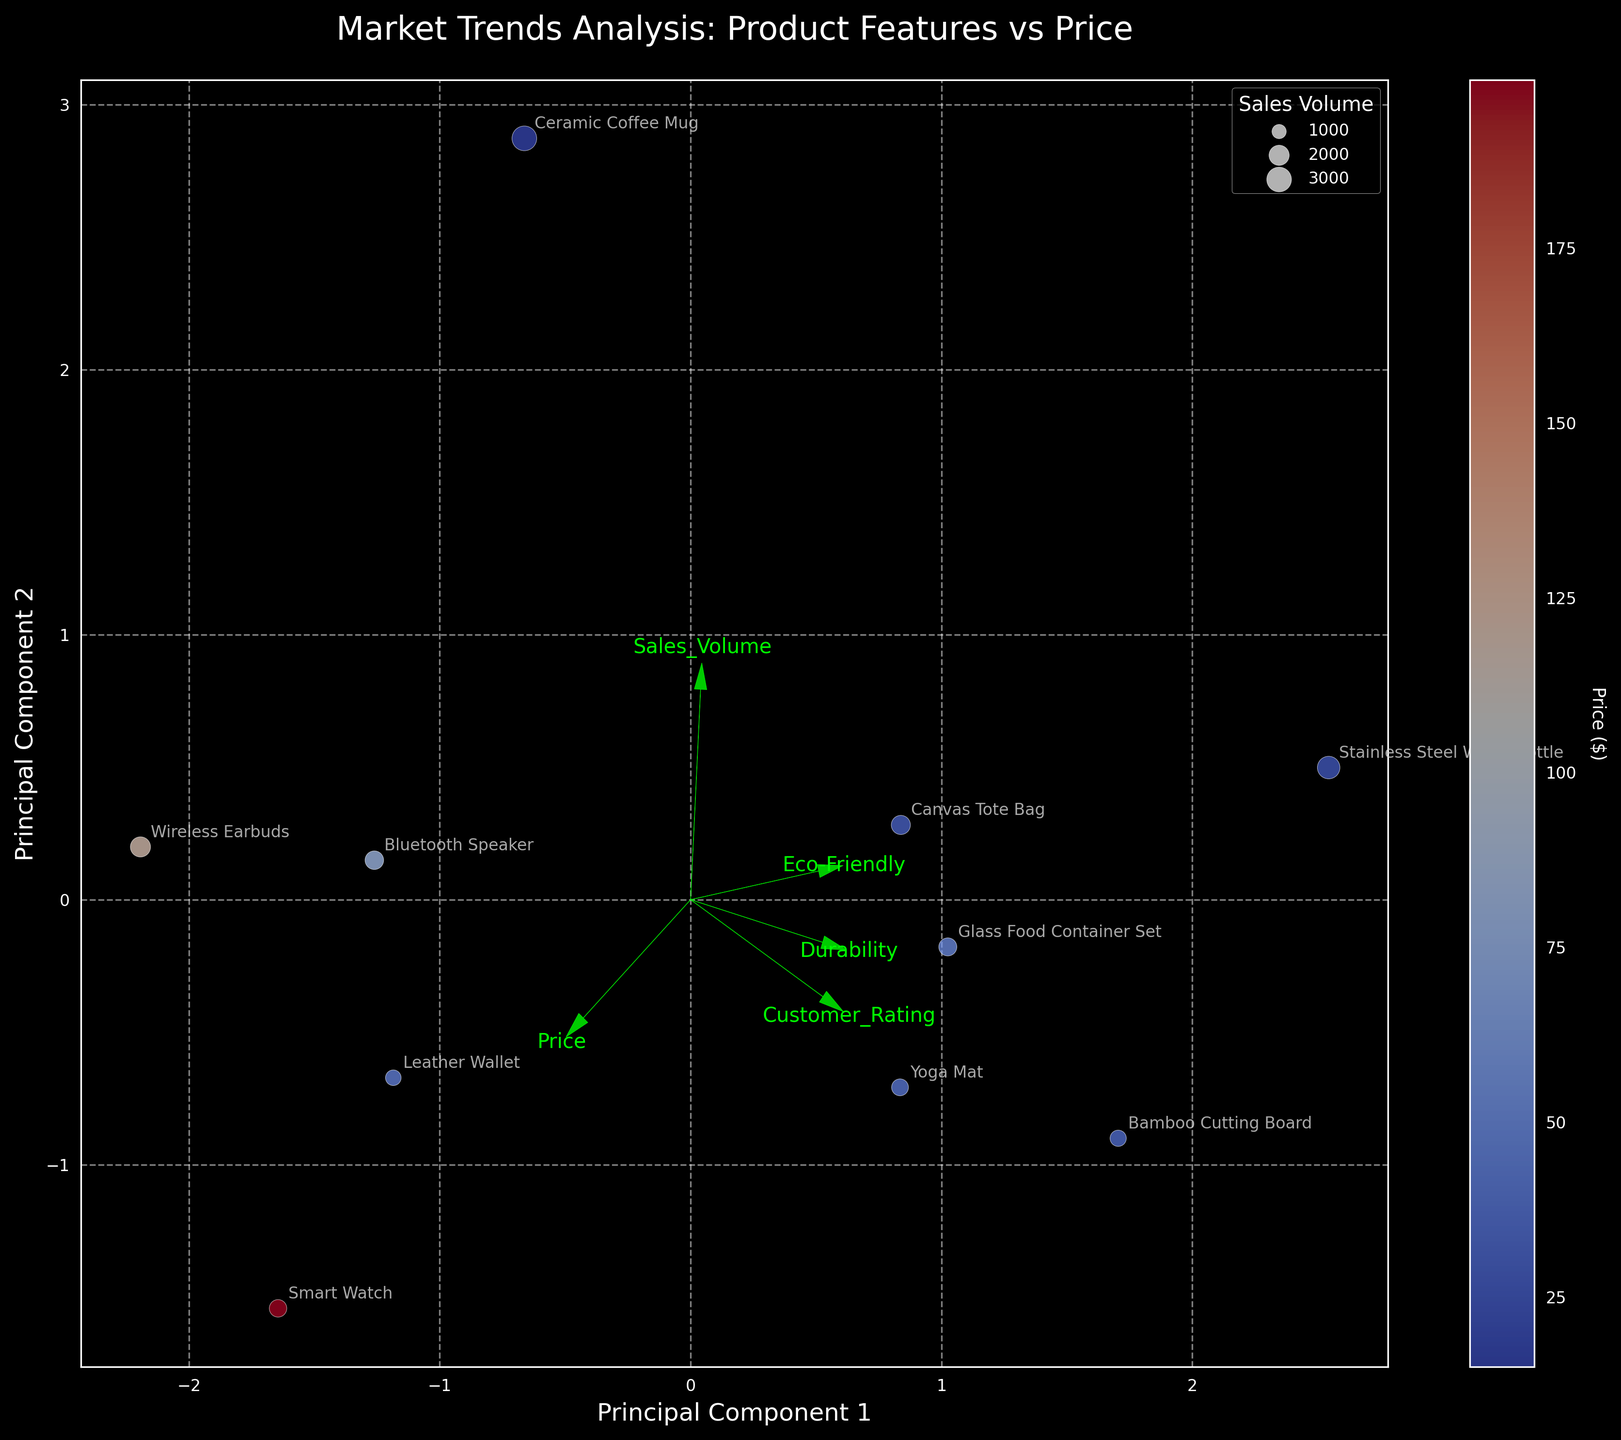How many products are displayed in the plot? Count the number of unique data points annotated with product names on the biplot. There are visible points like "Leather Wallet", "Canvas Tote Bag", and so on. Counting all annotated points gives the total number of products.
Answer: 10 Which feature has the longest vector in the biplot? Look for the green arrows representing features. Identify the arrow with the greatest magnitude (length). The longest vector signifies the feature that contributes most significantly to the variance in the data along the principal components.
Answer: Sales_Volume Which product has the highest sales volume, and where is it located on the plot? Identify the data point with the largest bubble size, since bubble size represents sales volume. Look for the "Ceramic Coffee Mug" annotation near this largest bubble size. It is found on the right side of the plot.
Answer: Ceramic Coffee Mug, right side Which feature has the strongest positive correlation with Principal Component 1? Check the arrows representing features. The feature arrow that most closely aligns with the positive direction of the Principal Component 1 axis indicates the strongest positive correlation with this axis.
Answer: Sales_Volume How does the price affect the position of products on the plot? Observing the color gradient on the bubbles, cooler colors (blues) indicate lower prices, while warmer colors (reds) represent higher prices. Products with higher prices appear to cluster on a specific region in the plot due to the color gradient.
Answer: Higher-priced products are found in the same region Which product is rated the highest by customers, and what is its position on the plot? Look for the product with the highest Customer_Rating feature, which is "Stainless Steel Water Bottle" rated at 4.7. Locate its annotation on the plot, which should be near a moderately sized bubble towards the top.
Answer: Stainless Steel Water Bottle, top region What can be inferred about the relationship between eco-friendliness and sales volume from the biplot? Look at the direction and length of the "Eco-Friendly" vector compared to "Sales_Volume". Both vectors point in somewhat similar directions, suggesting a positive relationship. Products with higher eco-friendliness tend to cluster where bubbles are relatively larger (indicating higher sales).
Answer: More eco-friendly products often have higher sales volumes Is there a noticeable pattern among products with high durability in terms of sales volume? Examine the vector representing "Durability" and check the profiles of products along the direction of this vector. Many products near this vector exhibit moderately sized bubbles, implying a moderate relationship between durability and sales volume.
Answer: High durability products tend to have moderate sales volumes Which two products are the most similar based on the biplot, and what features influence this similarity? Look for products that are closest together on the plot, indicating similar feature profiles. "Canvas Tote Bag" and "Bamboo Cutting Board" appear close. Analyze their vectors in relation to features like "Eco-Friendly" and "Durability" to confirm.
Answer: Canvas Tote Bag, Bamboo Cutting Board What conclusion can be drawn about the relationship between customer ratings and price for bestselling items? Observe the biplot to identify any clustering or patterns between the "Customer_Rating" vector and product color (representing price). Products with both high customer ratings and high prices tend to be grouped.
Answer: Higher-rated products can have both low and high prices 